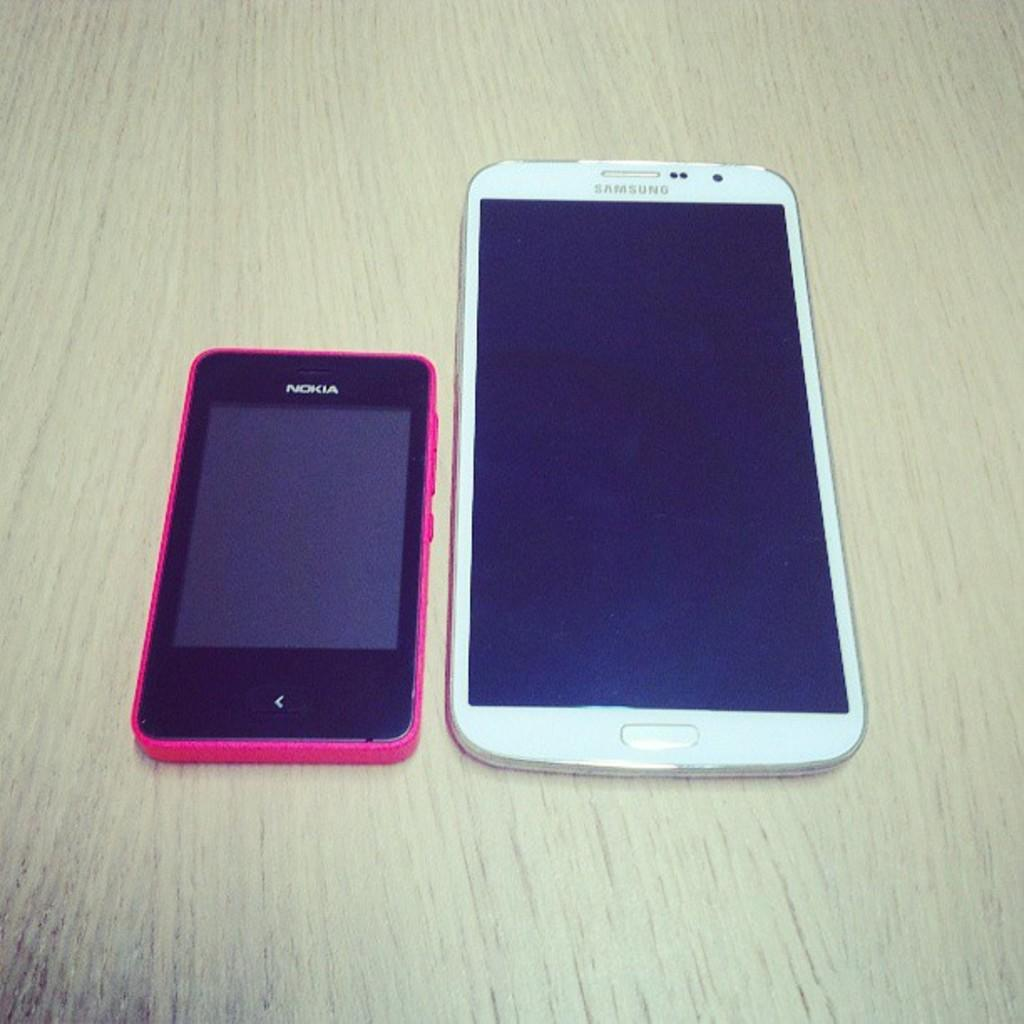<image>
Describe the image concisely. a Nokia phone and Samsung tablet (or phone?).. 